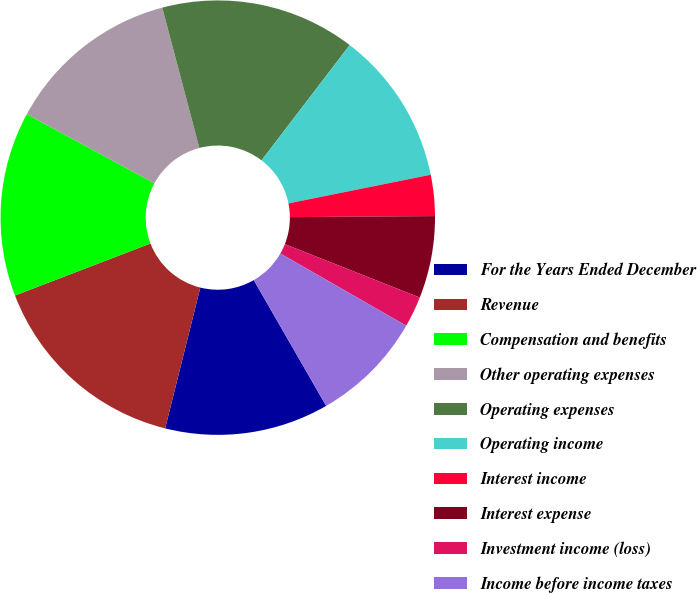Convert chart. <chart><loc_0><loc_0><loc_500><loc_500><pie_chart><fcel>For the Years Ended December<fcel>Revenue<fcel>Compensation and benefits<fcel>Other operating expenses<fcel>Operating expenses<fcel>Operating income<fcel>Interest income<fcel>Interest expense<fcel>Investment income (loss)<fcel>Income before income taxes<nl><fcel>12.21%<fcel>15.27%<fcel>13.74%<fcel>12.98%<fcel>14.5%<fcel>11.45%<fcel>3.05%<fcel>6.11%<fcel>2.29%<fcel>8.4%<nl></chart> 